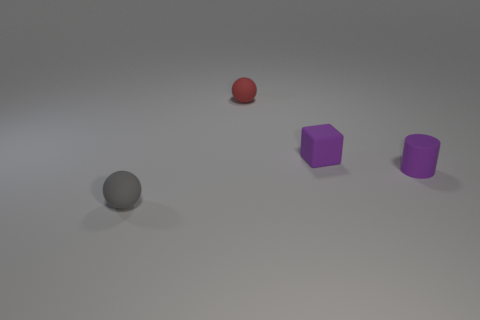Subtract 1 cylinders. How many cylinders are left? 0 Add 3 blue shiny blocks. How many blue shiny blocks exist? 3 Add 2 cylinders. How many objects exist? 6 Subtract all gray spheres. How many spheres are left? 1 Subtract 0 brown balls. How many objects are left? 4 Subtract all cubes. How many objects are left? 3 Subtract all cyan spheres. Subtract all brown cylinders. How many spheres are left? 2 Subtract all brown cubes. How many red balls are left? 1 Subtract all tiny green matte cubes. Subtract all small purple rubber things. How many objects are left? 2 Add 1 small red matte spheres. How many small red matte spheres are left? 2 